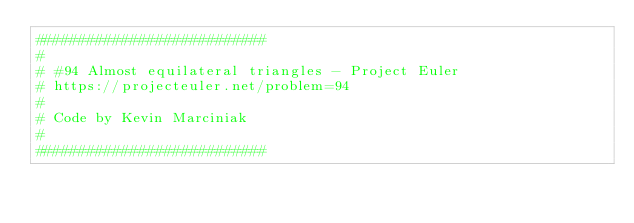<code> <loc_0><loc_0><loc_500><loc_500><_Python_>###########################
#
# #94 Almost equilateral triangles - Project Euler
# https://projecteuler.net/problem=94
#
# Code by Kevin Marciniak
#
###########################
</code> 